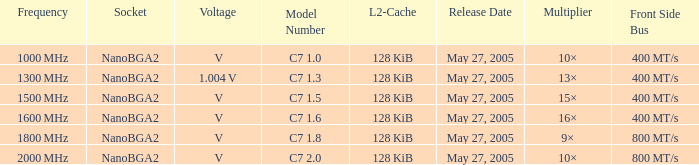5? 400 MT/s. 